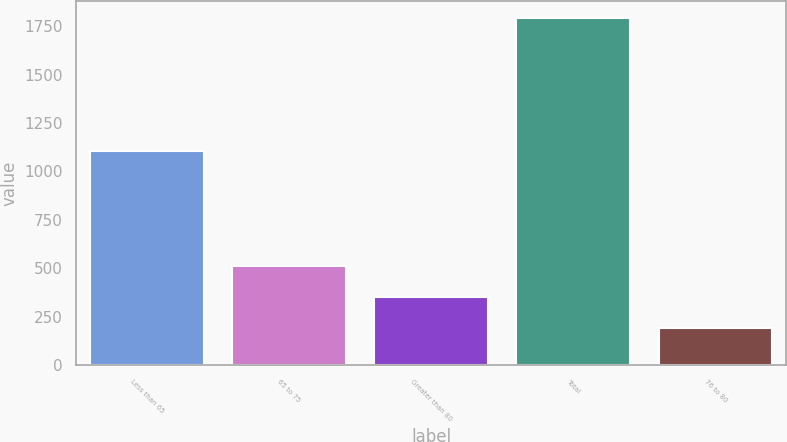Convert chart. <chart><loc_0><loc_0><loc_500><loc_500><bar_chart><fcel>Less than 65<fcel>65 to 75<fcel>Greater than 80<fcel>Total<fcel>76 to 80<nl><fcel>1105<fcel>511.8<fcel>351.9<fcel>1791<fcel>192<nl></chart> 